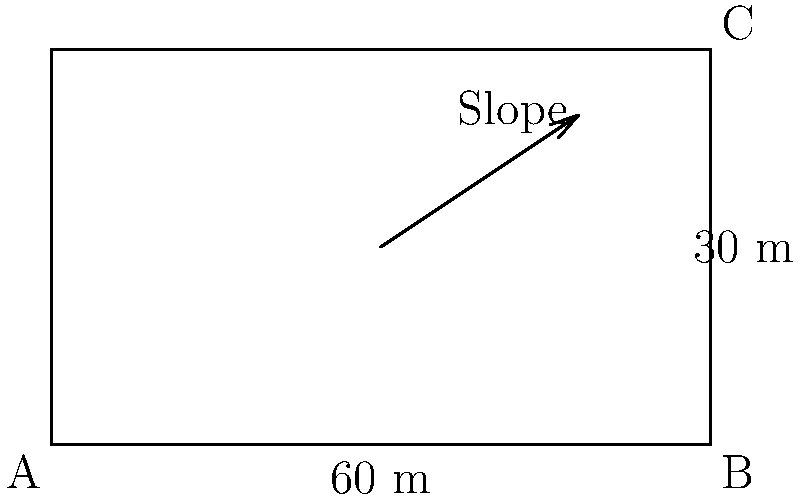As a customer service representative assisting with inventory management software, you're asked to help a civil engineer client calculate the optimal slope for water drainage in a parking lot design. Given a rectangular parking lot measuring 60 m by 30 m, what is the minimum slope required to ensure proper water drainage if the local building code specifies a minimum slope of 1%? To determine the optimal slope for water drainage, we need to follow these steps:

1. Understand the given information:
   - Parking lot dimensions: 60 m x 30 m
   - Minimum required slope: 1% (0.01 in decimal form)

2. Calculate the slope:
   - Slope is typically expressed as rise over run
   - In this case, we need to find the minimum rise for the given run

3. Determine the longest possible drainage path:
   - The longest path would be from one corner to the diagonally opposite corner
   - We can calculate this using the Pythagorean theorem:
     $$c = \sqrt{a^2 + b^2}$$
     where $c$ is the diagonal, and $a$ and $b$ are the sides
   - $$c = \sqrt{60^2 + 30^2} = \sqrt{3600 + 900} = \sqrt{4500} = 67.08 \text{ m}$$

4. Calculate the minimum rise:
   - Minimum rise = Longest path × Minimum slope
   - $$\text{Minimum rise} = 67.08 \text{ m} \times 0.01 = 0.6708 \text{ m}$$

5. Convert the rise to centimeters for practical application:
   - $$0.6708 \text{ m} \times 100 = 67.08 \text{ cm}$$

Therefore, to ensure proper water drainage, the parking lot should have a minimum rise of 67.08 cm from its lowest point to its highest point along the diagonal.
Answer: 67.08 cm rise over the 67.08 m diagonal 